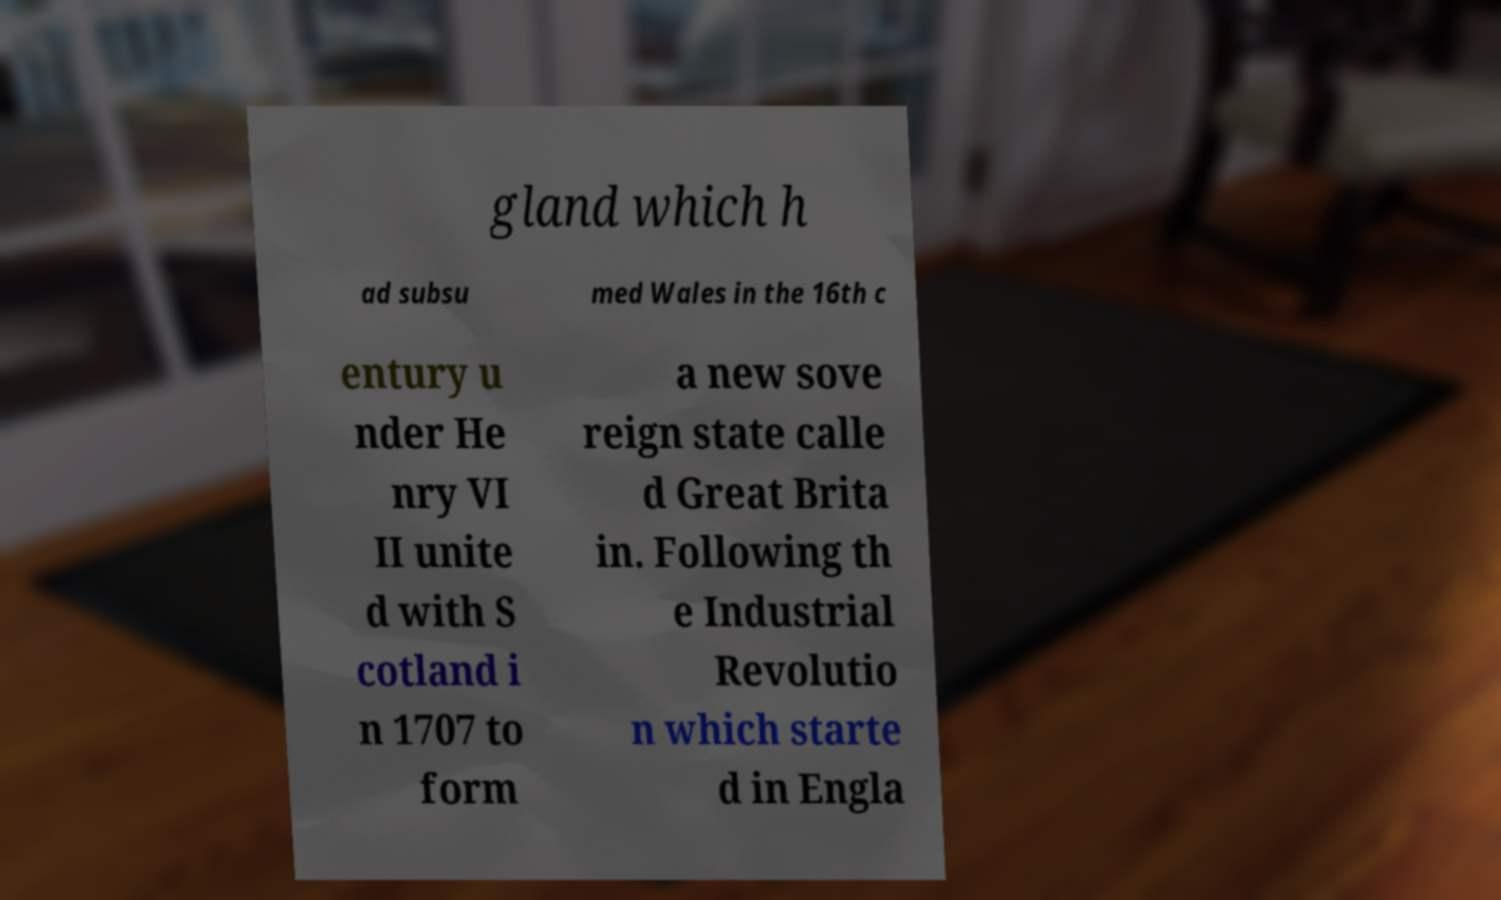I need the written content from this picture converted into text. Can you do that? gland which h ad subsu med Wales in the 16th c entury u nder He nry VI II unite d with S cotland i n 1707 to form a new sove reign state calle d Great Brita in. Following th e Industrial Revolutio n which starte d in Engla 